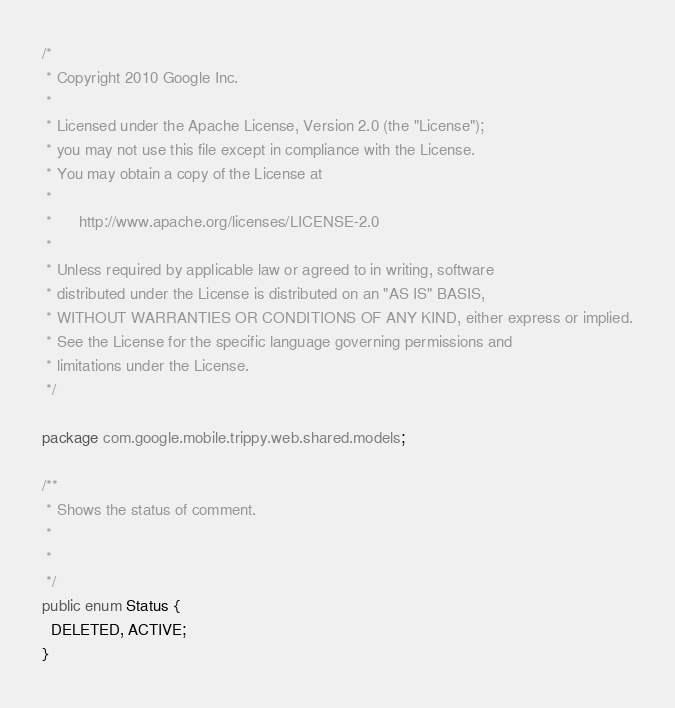<code> <loc_0><loc_0><loc_500><loc_500><_Java_>/*
 * Copyright 2010 Google Inc.
 *
 * Licensed under the Apache License, Version 2.0 (the "License");
 * you may not use this file except in compliance with the License.
 * You may obtain a copy of the License at
 *
 *      http://www.apache.org/licenses/LICENSE-2.0
 *
 * Unless required by applicable law or agreed to in writing, software
 * distributed under the License is distributed on an "AS IS" BASIS,
 * WITHOUT WARRANTIES OR CONDITIONS OF ANY KIND, either express or implied.
 * See the License for the specific language governing permissions and
 * limitations under the License.
 */

package com.google.mobile.trippy.web.shared.models;

/**
 * Shows the status of comment.
 * 
 *
 */
public enum Status {
  DELETED, ACTIVE;
}
</code> 